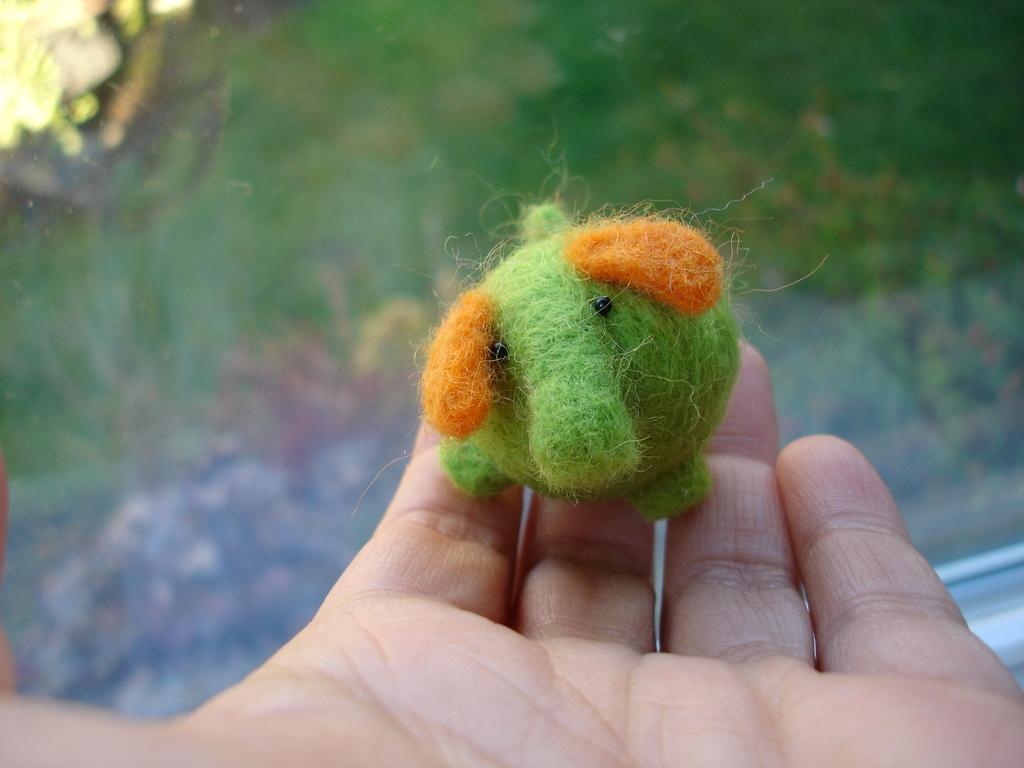What object is being held by a person in the image? There is a stuffed toy in the image, and it is being held by a person. Can you describe the stuffed toy in the image? Unfortunately, the rest of the image appears blurry, so it is difficult to provide more details about the stuffed toy. What type of week is being celebrated in the image? There is no indication of a week or any celebration in the image; it only features a person holding a stuffed toy. 